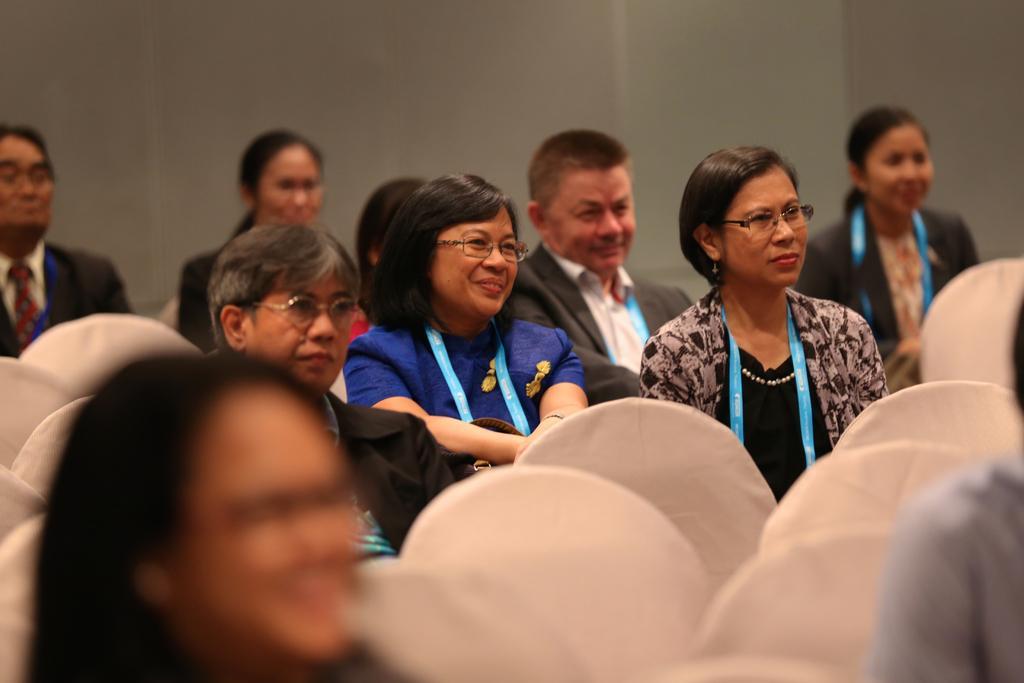Please provide a concise description of this image. In this image we can see people sitting on the chairs and there is a wall in the background. 